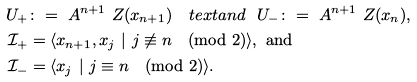<formula> <loc_0><loc_0><loc_500><loc_500>U _ { + } & \colon = \ A ^ { n + 1 } \ Z ( x _ { n + 1 } ) \quad t e x t { a n d } \ \ U _ { - } \colon = \ A ^ { n + 1 } \ Z ( x _ { n } ) , \\ \mathcal { I } _ { + } & = \langle x _ { n + 1 } , x _ { j } \ | \ j \not \equiv n \pmod { 2 } \rangle , \text { and} \\ \mathcal { I } _ { - } & = \langle x _ { j } \ | \ j \equiv n \pmod { 2 } \rangle .</formula> 